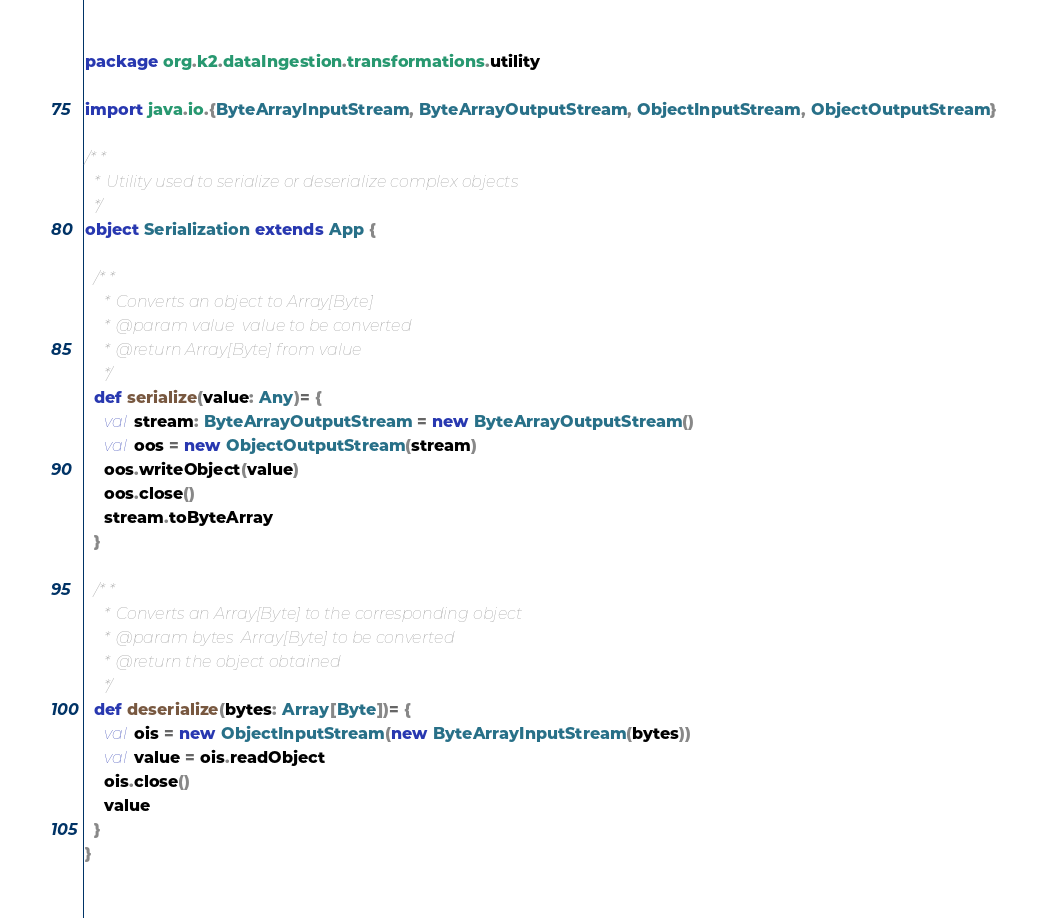<code> <loc_0><loc_0><loc_500><loc_500><_Scala_>package org.k2.dataIngestion.transformations.utility

import java.io.{ByteArrayInputStream, ByteArrayOutputStream, ObjectInputStream, ObjectOutputStream}

/**
  * Utility used to serialize or deserialize complex objects
  */
object Serialization extends App {

  /**
    * Converts an object to Array[Byte]
    * @param value  value to be converted
    * @return Array[Byte] from value
    */
  def serialize(value: Any)= {
    val stream: ByteArrayOutputStream = new ByteArrayOutputStream()
    val oos = new ObjectOutputStream(stream)
    oos.writeObject(value)
    oos.close()
    stream.toByteArray
  }

  /**
    * Converts an Array[Byte] to the corresponding object
    * @param bytes  Array[Byte] to be converted
    * @return the object obtained
    */
  def deserialize(bytes: Array[Byte])= {
    val ois = new ObjectInputStream(new ByteArrayInputStream(bytes))
    val value = ois.readObject
    ois.close()
    value
  }
}</code> 